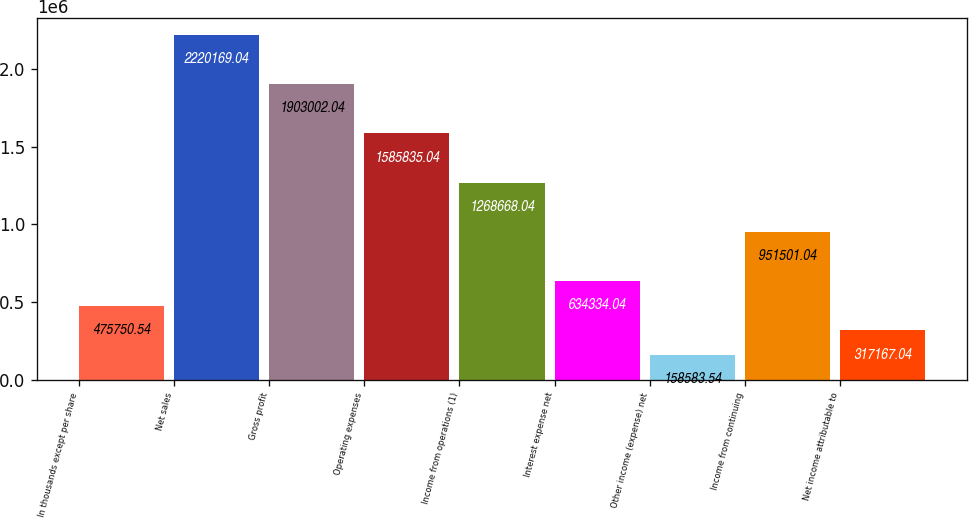<chart> <loc_0><loc_0><loc_500><loc_500><bar_chart><fcel>In thousands except per share<fcel>Net sales<fcel>Gross profit<fcel>Operating expenses<fcel>Income from operations (1)<fcel>Interest expense net<fcel>Other income (expense) net<fcel>Income from continuing<fcel>Net income attributable to<nl><fcel>475751<fcel>2.22017e+06<fcel>1.903e+06<fcel>1.58584e+06<fcel>1.26867e+06<fcel>634334<fcel>158584<fcel>951501<fcel>317167<nl></chart> 